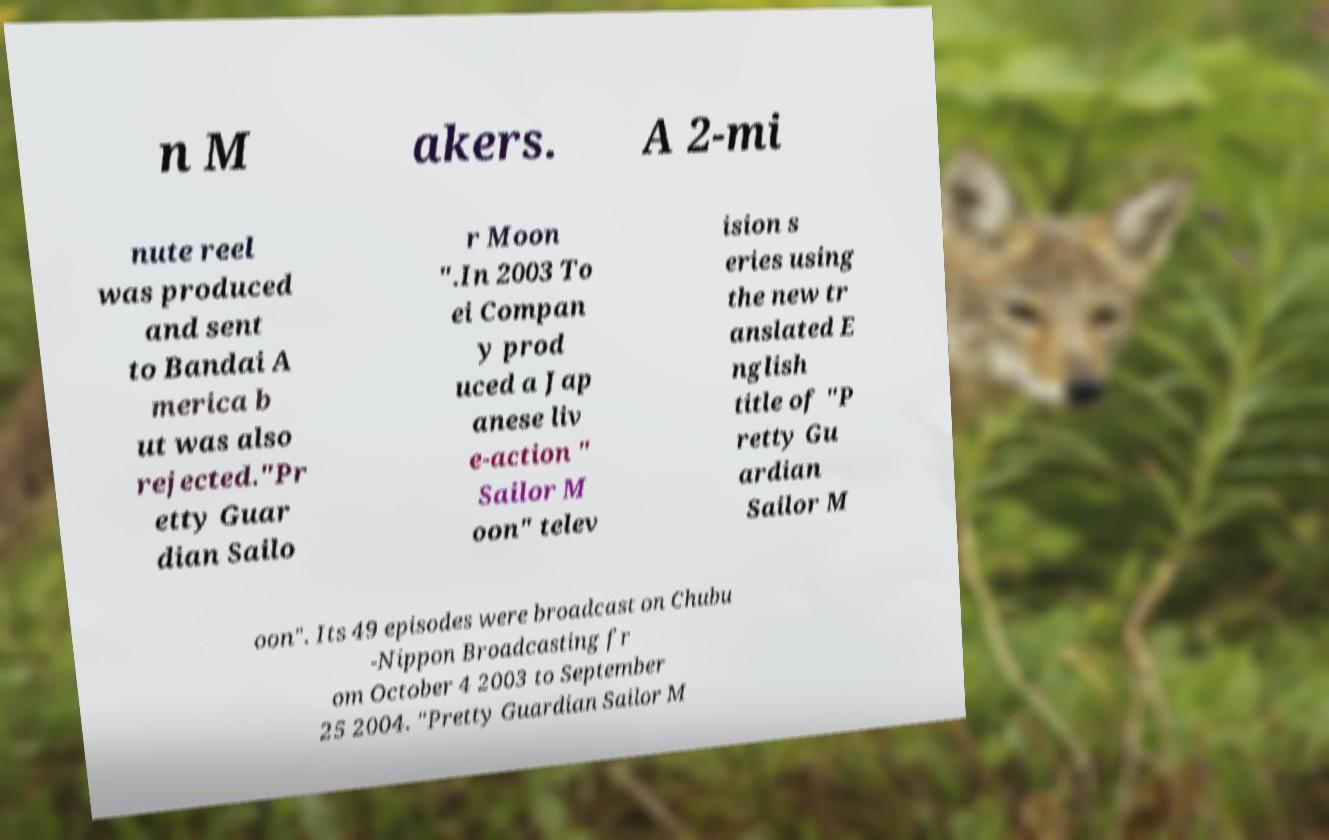Can you read and provide the text displayed in the image?This photo seems to have some interesting text. Can you extract and type it out for me? n M akers. A 2-mi nute reel was produced and sent to Bandai A merica b ut was also rejected."Pr etty Guar dian Sailo r Moon ".In 2003 To ei Compan y prod uced a Jap anese liv e-action " Sailor M oon" telev ision s eries using the new tr anslated E nglish title of "P retty Gu ardian Sailor M oon". Its 49 episodes were broadcast on Chubu -Nippon Broadcasting fr om October 4 2003 to September 25 2004. "Pretty Guardian Sailor M 